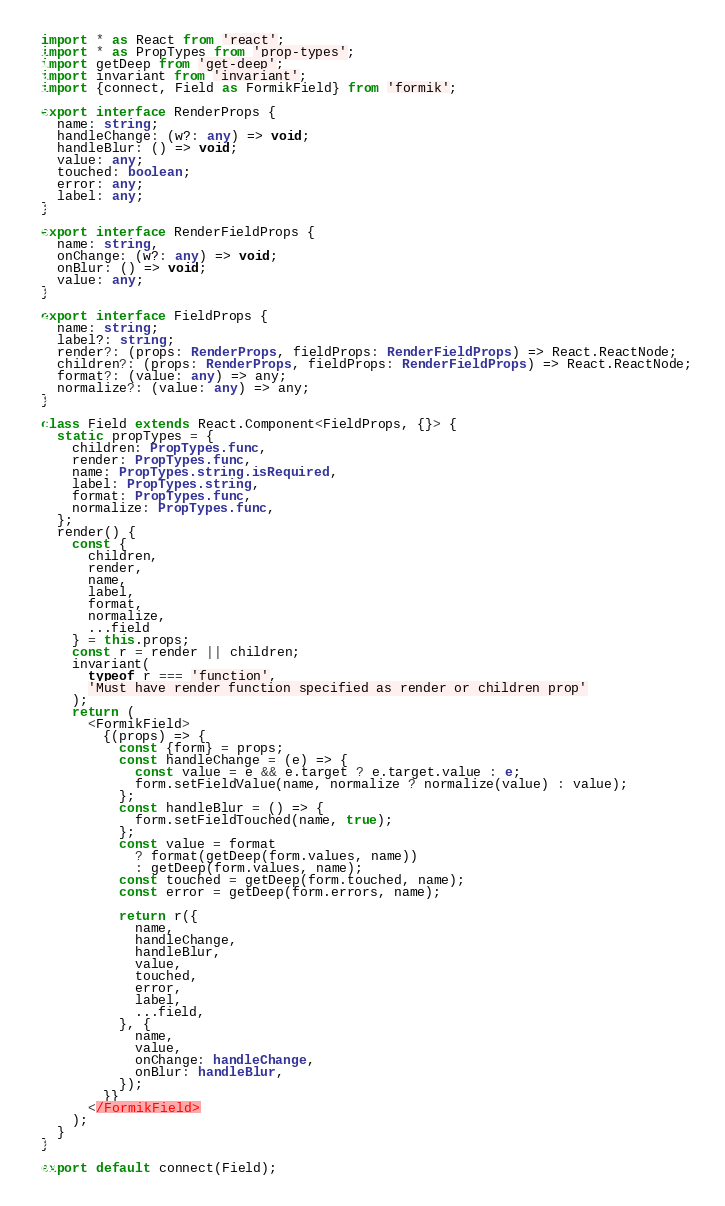<code> <loc_0><loc_0><loc_500><loc_500><_TypeScript_>import * as React from 'react';
import * as PropTypes from 'prop-types';
import getDeep from 'get-deep';
import invariant from 'invariant';
import {connect, Field as FormikField} from 'formik';

export interface RenderProps {
  name: string;
  handleChange: (w?: any) => void;
  handleBlur: () => void;
  value: any;
  touched: boolean;
  error: any;
  label: any;
}

export interface RenderFieldProps {
  name: string,
  onChange: (w?: any) => void;
  onBlur: () => void;
  value: any;
}

export interface FieldProps {
  name: string;
  label?: string;
  render?: (props: RenderProps, fieldProps: RenderFieldProps) => React.ReactNode;
  children?: (props: RenderProps, fieldProps: RenderFieldProps) => React.ReactNode;
  format?: (value: any) => any;
  normalize?: (value: any) => any;
}

class Field extends React.Component<FieldProps, {}> {
  static propTypes = {
    children: PropTypes.func,
    render: PropTypes.func,
    name: PropTypes.string.isRequired,
    label: PropTypes.string,
    format: PropTypes.func,
    normalize: PropTypes.func,
  };
  render() {
    const {
      children,
      render,
      name,
      label,
      format,
      normalize,
      ...field
    } = this.props;
    const r = render || children;
    invariant(
      typeof r === 'function',
      'Must have render function specified as render or children prop'
    );
    return (
      <FormikField>
        {(props) => {
          const {form} = props;
          const handleChange = (e) => {
            const value = e && e.target ? e.target.value : e;
            form.setFieldValue(name, normalize ? normalize(value) : value);
          };
          const handleBlur = () => {
            form.setFieldTouched(name, true);
          };
          const value = format
            ? format(getDeep(form.values, name))
            : getDeep(form.values, name);
          const touched = getDeep(form.touched, name);
          const error = getDeep(form.errors, name);

          return r({
            name,
            handleChange,
            handleBlur,
            value,
            touched,
            error,
            label,
            ...field,
          }, {
            name,
            value,
            onChange: handleChange,
            onBlur: handleBlur,
          });
        }}
      </FormikField>
    );
  }
}

export default connect(Field);
</code> 